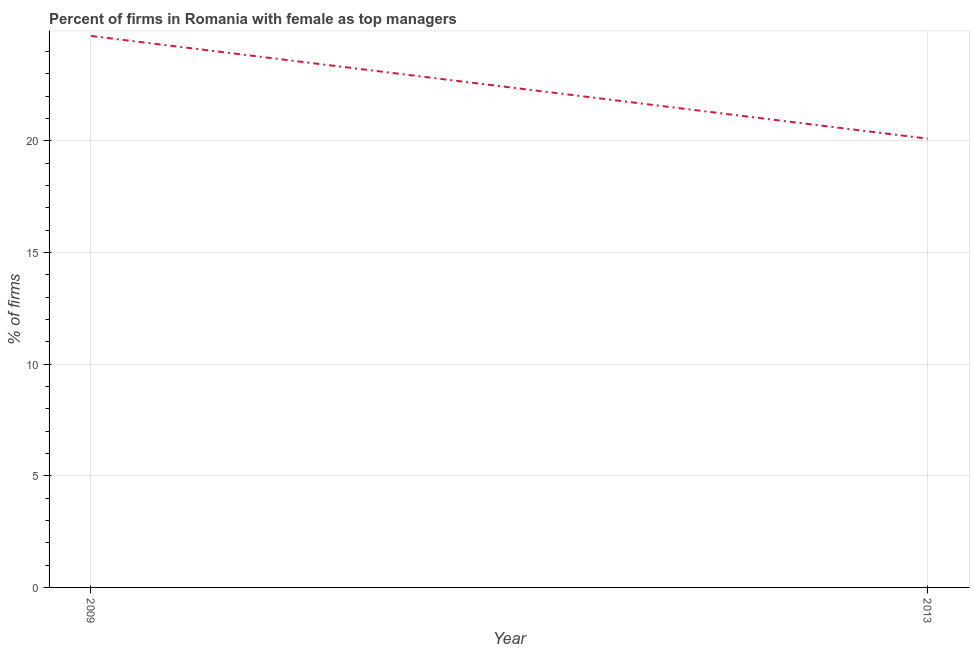What is the percentage of firms with female as top manager in 2013?
Make the answer very short. 20.1. Across all years, what is the maximum percentage of firms with female as top manager?
Give a very brief answer. 24.7. Across all years, what is the minimum percentage of firms with female as top manager?
Make the answer very short. 20.1. In which year was the percentage of firms with female as top manager minimum?
Provide a succinct answer. 2013. What is the sum of the percentage of firms with female as top manager?
Ensure brevity in your answer.  44.8. What is the difference between the percentage of firms with female as top manager in 2009 and 2013?
Offer a terse response. 4.6. What is the average percentage of firms with female as top manager per year?
Offer a terse response. 22.4. What is the median percentage of firms with female as top manager?
Your response must be concise. 22.4. Do a majority of the years between 2013 and 2009 (inclusive) have percentage of firms with female as top manager greater than 22 %?
Your response must be concise. No. What is the ratio of the percentage of firms with female as top manager in 2009 to that in 2013?
Your answer should be compact. 1.23. Is the percentage of firms with female as top manager in 2009 less than that in 2013?
Your answer should be very brief. No. In how many years, is the percentage of firms with female as top manager greater than the average percentage of firms with female as top manager taken over all years?
Your answer should be compact. 1. Does the percentage of firms with female as top manager monotonically increase over the years?
Provide a short and direct response. No. How many years are there in the graph?
Offer a very short reply. 2. What is the difference between two consecutive major ticks on the Y-axis?
Provide a short and direct response. 5. Are the values on the major ticks of Y-axis written in scientific E-notation?
Your answer should be compact. No. Does the graph contain grids?
Provide a succinct answer. Yes. What is the title of the graph?
Your response must be concise. Percent of firms in Romania with female as top managers. What is the label or title of the Y-axis?
Give a very brief answer. % of firms. What is the % of firms in 2009?
Provide a short and direct response. 24.7. What is the % of firms in 2013?
Your answer should be compact. 20.1. What is the ratio of the % of firms in 2009 to that in 2013?
Ensure brevity in your answer.  1.23. 